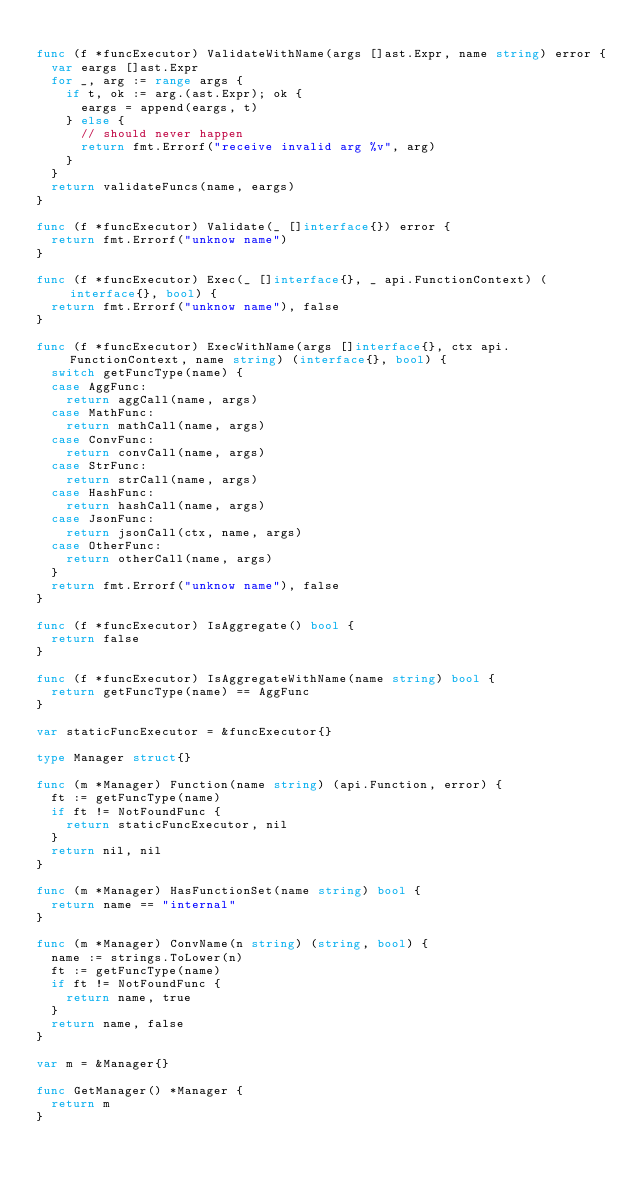Convert code to text. <code><loc_0><loc_0><loc_500><loc_500><_Go_>
func (f *funcExecutor) ValidateWithName(args []ast.Expr, name string) error {
	var eargs []ast.Expr
	for _, arg := range args {
		if t, ok := arg.(ast.Expr); ok {
			eargs = append(eargs, t)
		} else {
			// should never happen
			return fmt.Errorf("receive invalid arg %v", arg)
		}
	}
	return validateFuncs(name, eargs)
}

func (f *funcExecutor) Validate(_ []interface{}) error {
	return fmt.Errorf("unknow name")
}

func (f *funcExecutor) Exec(_ []interface{}, _ api.FunctionContext) (interface{}, bool) {
	return fmt.Errorf("unknow name"), false
}

func (f *funcExecutor) ExecWithName(args []interface{}, ctx api.FunctionContext, name string) (interface{}, bool) {
	switch getFuncType(name) {
	case AggFunc:
		return aggCall(name, args)
	case MathFunc:
		return mathCall(name, args)
	case ConvFunc:
		return convCall(name, args)
	case StrFunc:
		return strCall(name, args)
	case HashFunc:
		return hashCall(name, args)
	case JsonFunc:
		return jsonCall(ctx, name, args)
	case OtherFunc:
		return otherCall(name, args)
	}
	return fmt.Errorf("unknow name"), false
}

func (f *funcExecutor) IsAggregate() bool {
	return false
}

func (f *funcExecutor) IsAggregateWithName(name string) bool {
	return getFuncType(name) == AggFunc
}

var staticFuncExecutor = &funcExecutor{}

type Manager struct{}

func (m *Manager) Function(name string) (api.Function, error) {
	ft := getFuncType(name)
	if ft != NotFoundFunc {
		return staticFuncExecutor, nil
	}
	return nil, nil
}

func (m *Manager) HasFunctionSet(name string) bool {
	return name == "internal"
}

func (m *Manager) ConvName(n string) (string, bool) {
	name := strings.ToLower(n)
	ft := getFuncType(name)
	if ft != NotFoundFunc {
		return name, true
	}
	return name, false
}

var m = &Manager{}

func GetManager() *Manager {
	return m
}
</code> 